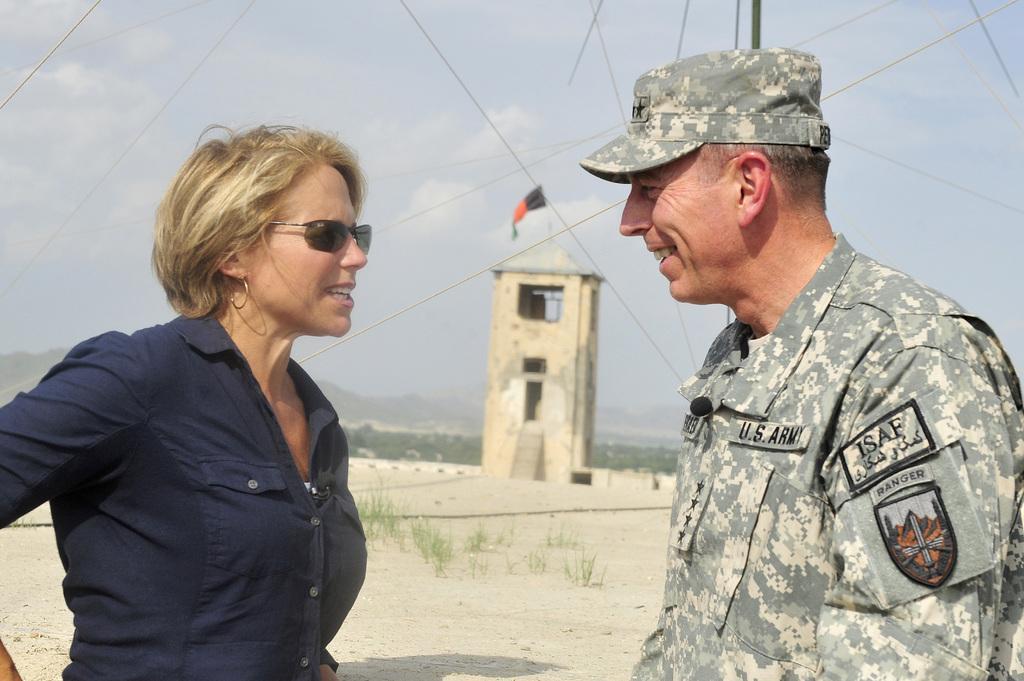How would you summarize this image in a sentence or two? In this picture there are two persons standing and talking each other and there is a tower which has a flag above it and there are trees and mountains in the background. 